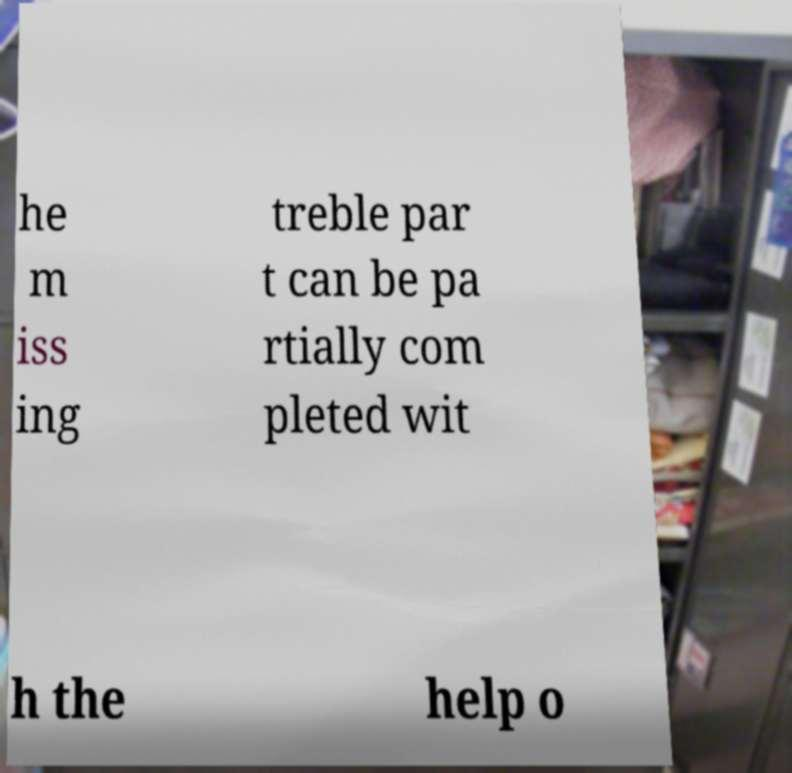There's text embedded in this image that I need extracted. Can you transcribe it verbatim? he m iss ing treble par t can be pa rtially com pleted wit h the help o 